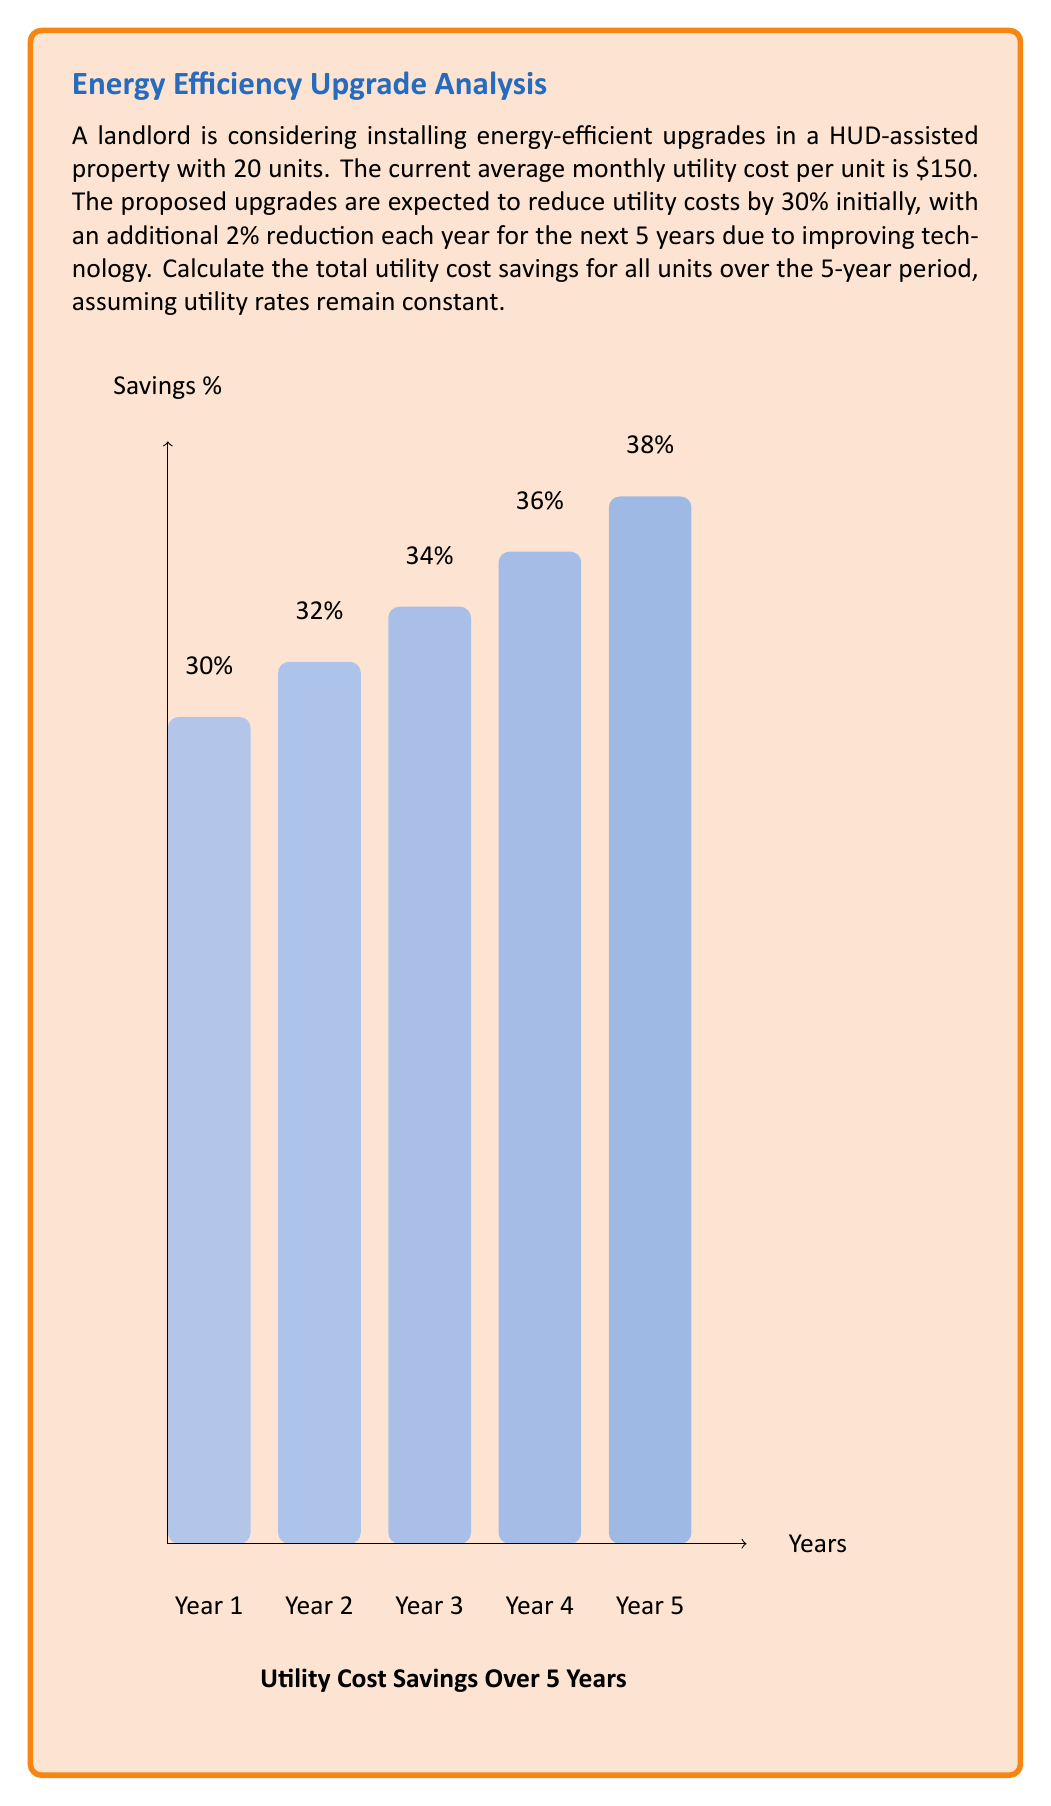Teach me how to tackle this problem. Let's break this down step-by-step:

1) First, calculate the initial monthly savings per unit:
   $150 \times 30\% = $45$ per unit per month

2) Calculate the yearly savings for all 20 units in the first year:
   $45 \times 20 \text{ units} \times 12 \text{ months} = $10,800$ for Year 1

3) For each subsequent year, increase the savings percentage by 2%:
   Year 2: 32%, Year 3: 34%, Year 4: 36%, Year 5: 38%

4) Calculate the savings for each year:
   Year 2: $150 \times 32\% \times 20 \times 12 = $11,520$
   Year 3: $150 \times 34\% \times 20 \times 12 = $12,240$
   Year 4: $150 \times 36\% \times 20 \times 12 = $12,960$
   Year 5: $150 \times 38\% \times 20 \times 12 = $13,680$

5) Sum up the savings for all 5 years:
   $10,800 + $11,520 + $12,240 + $12,960 + $13,680 = $61,200$

Therefore, the total utility cost savings over the 5-year period for all units is $61,200.
Answer: $61,200 